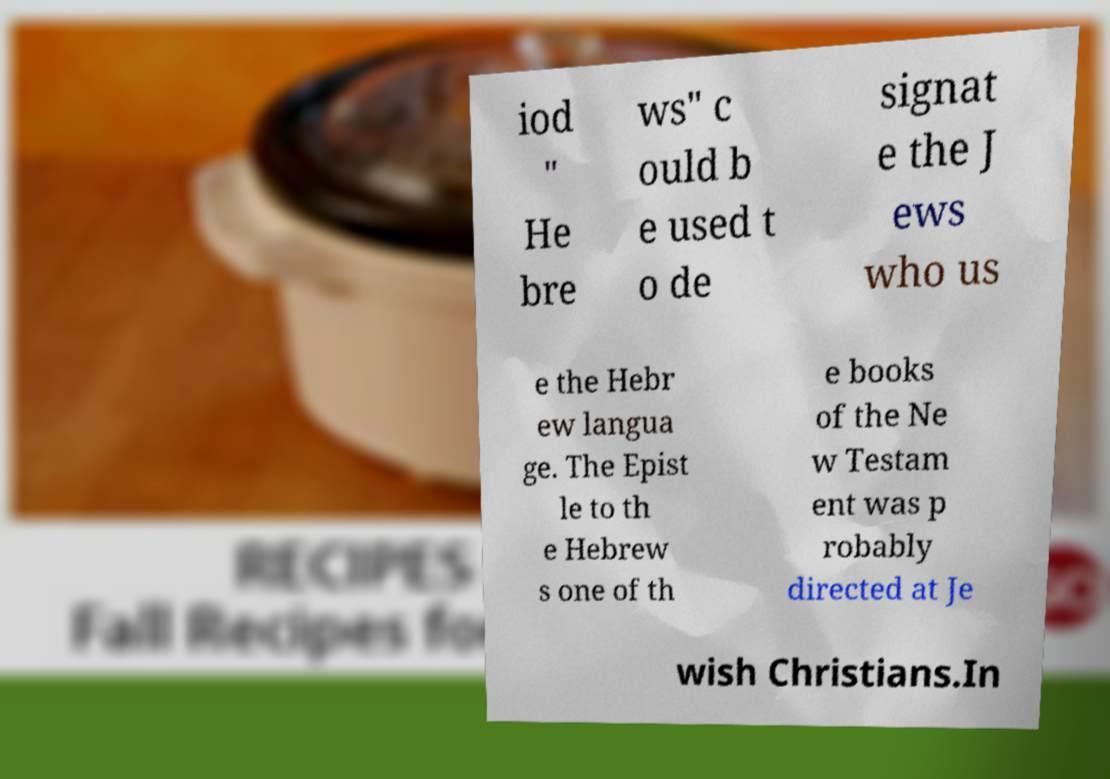Please identify and transcribe the text found in this image. iod " He bre ws" c ould b e used t o de signat e the J ews who us e the Hebr ew langua ge. The Epist le to th e Hebrew s one of th e books of the Ne w Testam ent was p robably directed at Je wish Christians.In 